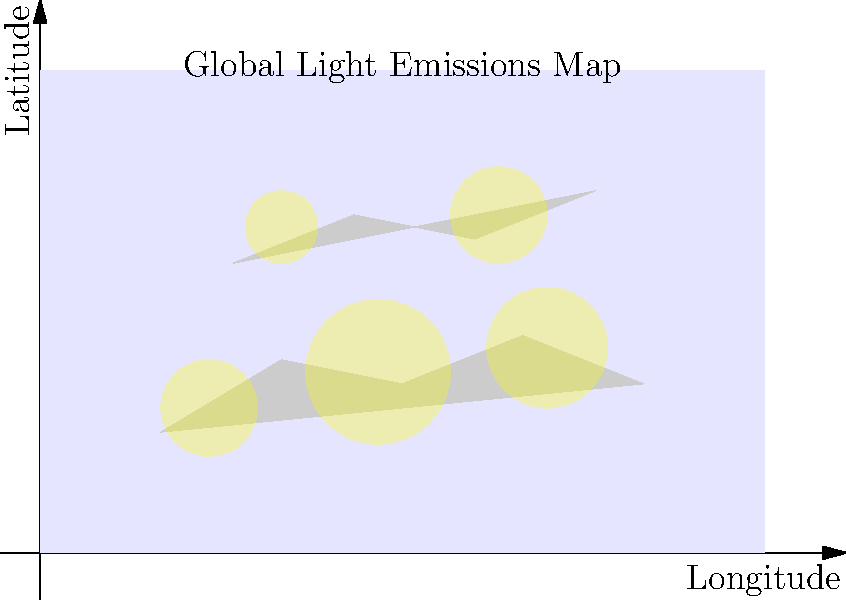Based on the global light emissions map provided, which regions are likely to experience the most significant impact on nocturnal wildlife due to light pollution? How might this information influence your approach to negotiating international wildlife protection treaties? To answer this question, we need to analyze the map and consider the implications of light pollution on nocturnal wildlife:

1. Identify high light emission areas:
   - The map shows five main areas of light emissions, represented by yellow circles.
   - The largest concentrations appear to be in the northern hemisphere, with three major sources.
   - Two smaller sources are visible in the southern hemisphere.

2. Impact on nocturnal wildlife:
   - Nocturnal animals rely on darkness for various activities, including hunting, mating, and navigation.
   - Light pollution can disrupt these natural behaviors, leading to:
     a) Changes in predator-prey relationships
     b) Altered reproductive cycles
     c) Disorientation of migratory species

3. Most affected regions:
   - Areas with the largest and most intense light sources will likely have the most significant impact on nocturnal wildlife.
   - In this map, the northern hemisphere, particularly the areas around the three largest light sources, would be of greatest concern.

4. Considerations for treaty negotiations:
   - Focus on regions with high light emissions for immediate action.
   - Propose international standards for light pollution reduction.
   - Encourage research on the specific impacts of light pollution on local nocturnal species.
   - Develop strategies for creating dark sky preserves or corridors between heavily lit areas.
   - Promote the use of wildlife-friendly lighting technologies.
   - Establish monitoring programs to track changes in nocturnal wildlife populations in relation to light pollution levels.

5. Collaborative approach:
   - Emphasize the transboundary nature of light pollution and its effects on migratory species.
   - Encourage information sharing and joint research initiatives between countries.
   - Propose economic incentives for countries that successfully reduce light pollution.

By considering these factors, a government official can develop a comprehensive approach to negotiating international treaties that address the impact of light pollution on nocturnal wildlife, focusing on the most affected areas while promoting global cooperation and sustainable lighting practices.
Answer: Northern hemisphere regions with large light sources; focus on international standards, research, dark sky preserves, and wildlife-friendly lighting in treaty negotiations. 